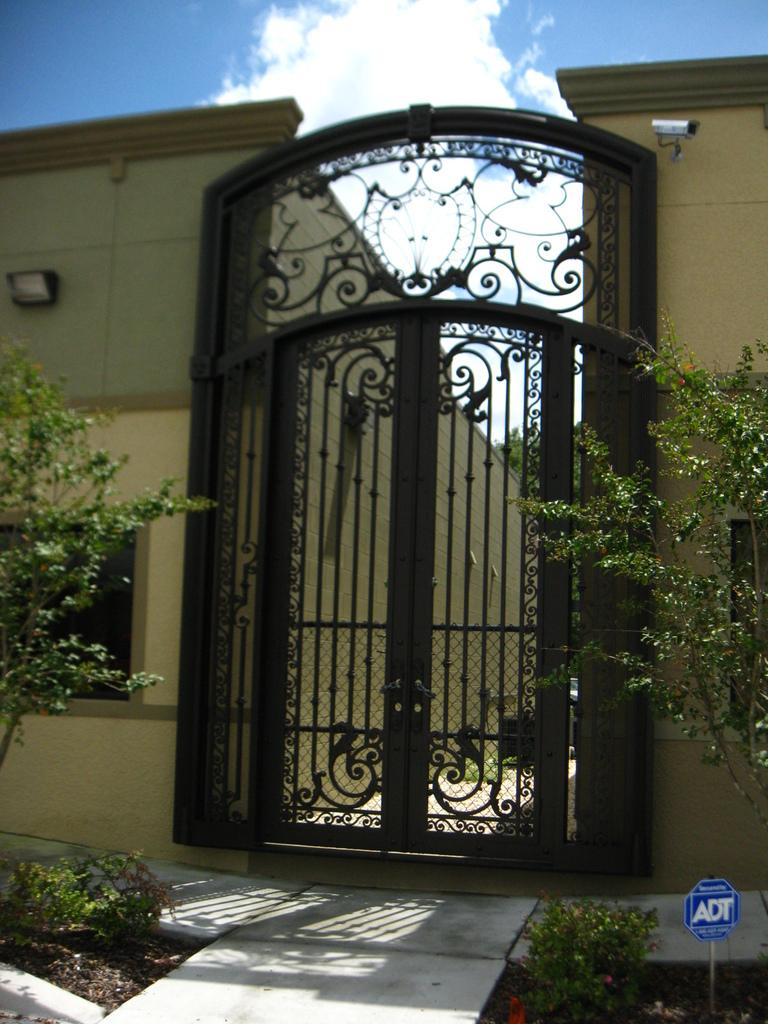What type of living organisms can be seen in the image? Plants can be seen in the image. What type of structure is present in the image? There is a gate in the image. What is used for identification purposes in the image? There is a name board in the image. What type of architectural features are visible in the image? There are walls in the image. What can be used for ventilation or viewing the outside in the image? There are windows in the image. What other objects can be seen in the image? There are some objects in the image. What type of vegetation is visible in the background of the image? Trees are visible in the background of the image. What is visible in the background of the image, apart from the trees? The sky is visible in the background of the image. What type of poison is being used to make the soup in the image? There is no soup or poison present in the image. What type of trail can be seen in the image? There is no trail visible in the image. 